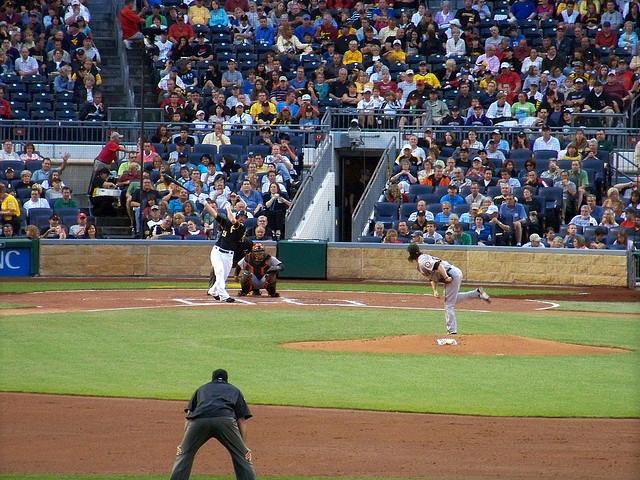What is the man in black doing?
Quick response, please. Umpiring. How many people in the stands?
Be succinct. Many. Who is wearing black at home plate?
Answer briefly. Batter. How many players are in this shot?
Give a very brief answer. 3. Did the batter hit the ball?
Concise answer only. Yes. 